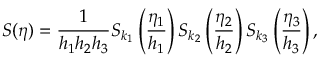Convert formula to latex. <formula><loc_0><loc_0><loc_500><loc_500>S ( \boldsymbol \eta ) = \frac { 1 } { h _ { 1 } h _ { 2 } h _ { 3 } } S _ { k _ { 1 } } \left ( \frac { \eta _ { 1 } } { h _ { 1 } } \right ) S _ { k _ { 2 } } \left ( \frac { \eta _ { 2 } } { h _ { 2 } } \right ) S _ { k _ { 3 } } \left ( \frac { \eta _ { 3 } } { h _ { 3 } } \right ) ,</formula> 